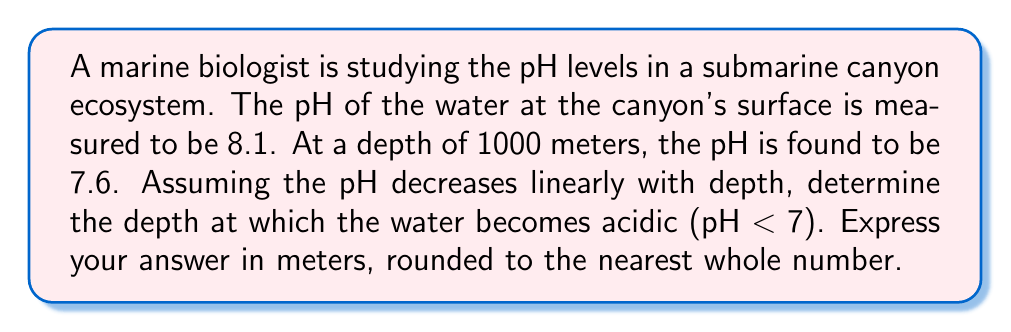Help me with this question. To solve this problem, we'll follow these steps:

1) First, let's recall that pH is defined as the negative logarithm (base 10) of the hydrogen ion concentration:

   $$ \text{pH} = -\log_{10}[\text{H}^+] $$

2) We're given that the pH decreases linearly with depth. Let's define a linear function for pH in terms of depth:

   $$ \text{pH} = mx + b $$

   where $x$ is the depth in meters, $m$ is the slope, and $b$ is the y-intercept (surface pH).

3) We can find the slope using the two given points:

   $$ m = \frac{\text{pH}_2 - \text{pH}_1}{\text{depth}_2 - \text{depth}_1} = \frac{7.6 - 8.1}{1000 - 0} = -0.0005 $$

4) Now we can write our linear function:

   $$ \text{pH} = -0.0005x + 8.1 $$

5) To find the depth where pH = 7, we solve the equation:

   $$ 7 = -0.0005x + 8.1 $$
   $$ -1.1 = -0.0005x $$
   $$ x = \frac{1.1}{0.0005} = 2200 $$

6) Therefore, the water becomes acidic (pH < 7) at a depth of 2200 meters.
Answer: 2200 meters 